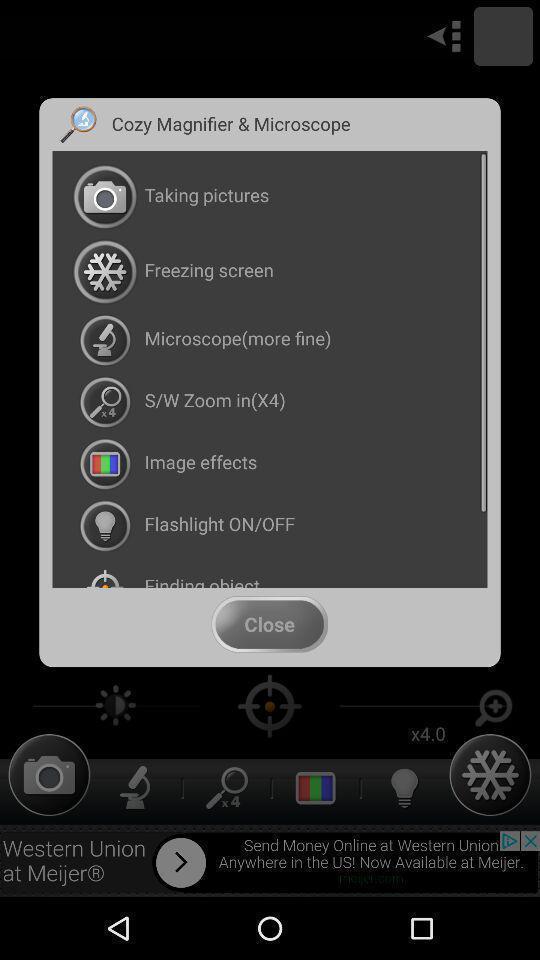Please provide a description for this image. Pop-up displaying various multiple options in a editing app. 